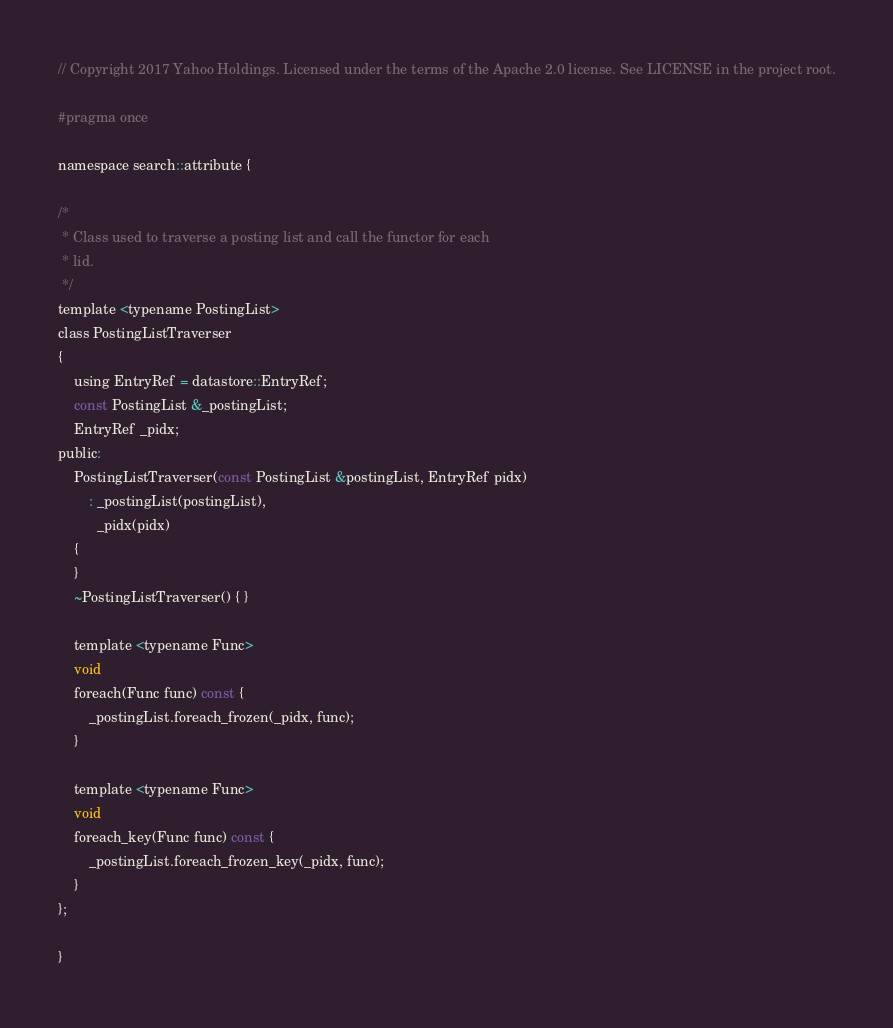<code> <loc_0><loc_0><loc_500><loc_500><_C_>// Copyright 2017 Yahoo Holdings. Licensed under the terms of the Apache 2.0 license. See LICENSE in the project root.

#pragma once

namespace search::attribute {

/*
 * Class used to traverse a posting list and call the functor for each
 * lid.
 */
template <typename PostingList>
class PostingListTraverser
{
    using EntryRef = datastore::EntryRef;
    const PostingList &_postingList;
    EntryRef _pidx;
public:
    PostingListTraverser(const PostingList &postingList, EntryRef pidx)
        : _postingList(postingList),
          _pidx(pidx)
    {
    }
    ~PostingListTraverser() { }

    template <typename Func>
    void
    foreach(Func func) const {
        _postingList.foreach_frozen(_pidx, func);
    }

    template <typename Func>
    void
    foreach_key(Func func) const {
        _postingList.foreach_frozen_key(_pidx, func);
    }
};

}
</code> 